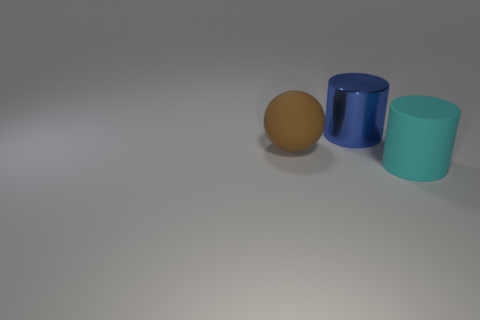What does the arrangement of these objects tell us about their possible interaction? The objects are placed parallel to each other with a small distance in between, which does not suggest any direct interaction between them. Instead, they seem to be positioned deliberately for observation or display. The arrangement could indicate a comparative study of shapes and sizes or be a simple, aesthetic composition. 